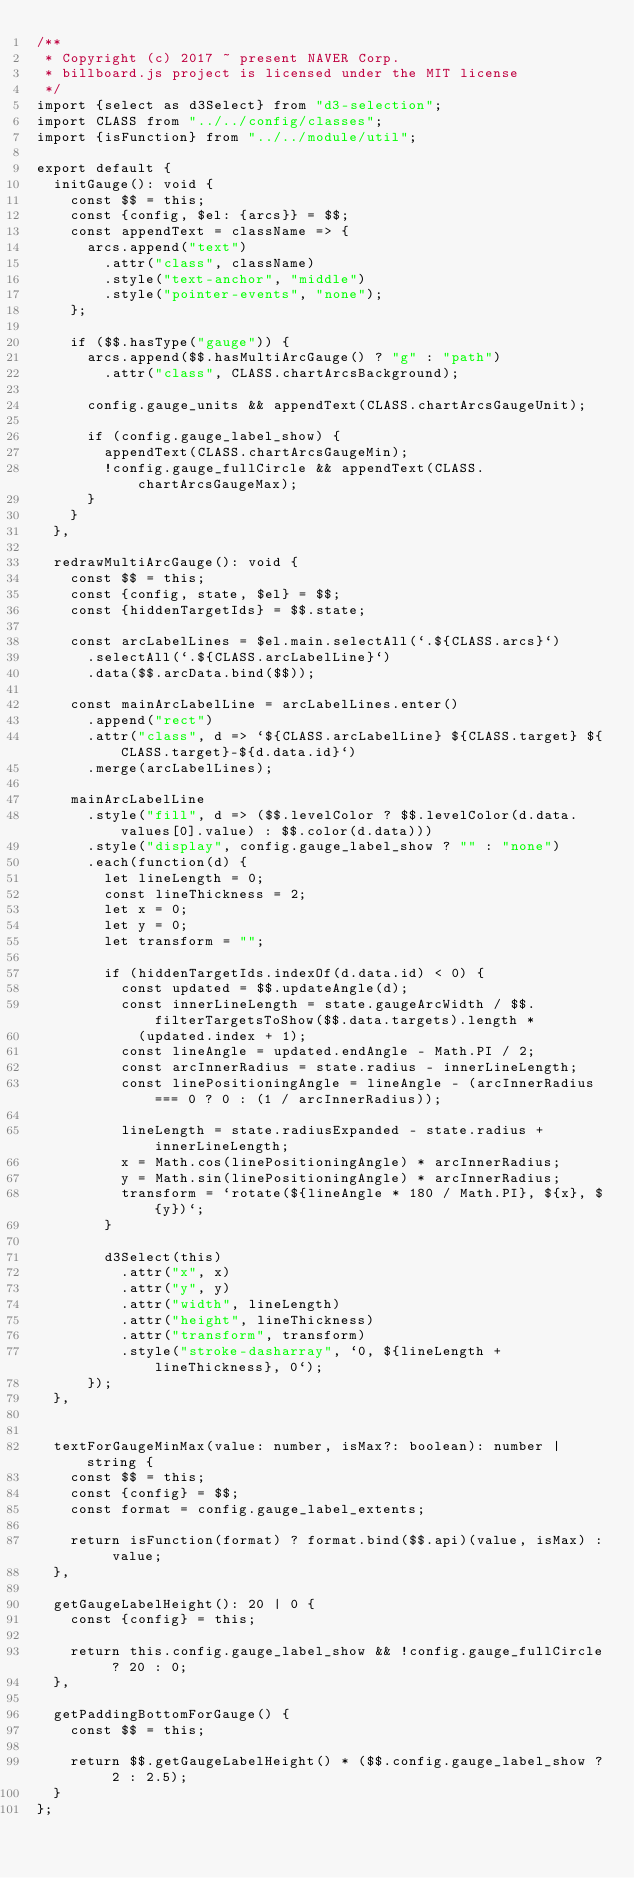<code> <loc_0><loc_0><loc_500><loc_500><_TypeScript_>/**
 * Copyright (c) 2017 ~ present NAVER Corp.
 * billboard.js project is licensed under the MIT license
 */
import {select as d3Select} from "d3-selection";
import CLASS from "../../config/classes";
import {isFunction} from "../../module/util";

export default {
	initGauge(): void {
		const $$ = this;
		const {config, $el: {arcs}} = $$;
		const appendText = className => {
			arcs.append("text")
				.attr("class", className)
				.style("text-anchor", "middle")
				.style("pointer-events", "none");
		};

		if ($$.hasType("gauge")) {
			arcs.append($$.hasMultiArcGauge() ? "g" : "path")
				.attr("class", CLASS.chartArcsBackground);

			config.gauge_units && appendText(CLASS.chartArcsGaugeUnit);

			if (config.gauge_label_show) {
				appendText(CLASS.chartArcsGaugeMin);
				!config.gauge_fullCircle && appendText(CLASS.chartArcsGaugeMax);
			}
		}
	},

	redrawMultiArcGauge(): void {
		const $$ = this;
		const {config, state, $el} = $$;
		const {hiddenTargetIds} = $$.state;

		const arcLabelLines = $el.main.selectAll(`.${CLASS.arcs}`)
			.selectAll(`.${CLASS.arcLabelLine}`)
			.data($$.arcData.bind($$));

		const mainArcLabelLine = arcLabelLines.enter()
			.append("rect")
			.attr("class", d => `${CLASS.arcLabelLine} ${CLASS.target} ${CLASS.target}-${d.data.id}`)
			.merge(arcLabelLines);

		mainArcLabelLine
			.style("fill", d => ($$.levelColor ? $$.levelColor(d.data.values[0].value) : $$.color(d.data)))
			.style("display", config.gauge_label_show ? "" : "none")
			.each(function(d) {
				let lineLength = 0;
				const lineThickness = 2;
				let x = 0;
				let y = 0;
				let transform = "";

				if (hiddenTargetIds.indexOf(d.data.id) < 0) {
					const updated = $$.updateAngle(d);
					const innerLineLength = state.gaugeArcWidth / $$.filterTargetsToShow($$.data.targets).length *
						(updated.index + 1);
					const lineAngle = updated.endAngle - Math.PI / 2;
					const arcInnerRadius = state.radius - innerLineLength;
					const linePositioningAngle = lineAngle - (arcInnerRadius === 0 ? 0 : (1 / arcInnerRadius));

					lineLength = state.radiusExpanded - state.radius + innerLineLength;
					x = Math.cos(linePositioningAngle) * arcInnerRadius;
					y = Math.sin(linePositioningAngle) * arcInnerRadius;
					transform = `rotate(${lineAngle * 180 / Math.PI}, ${x}, ${y})`;
				}

				d3Select(this)
					.attr("x", x)
					.attr("y", y)
					.attr("width", lineLength)
					.attr("height", lineThickness)
					.attr("transform", transform)
					.style("stroke-dasharray", `0, ${lineLength + lineThickness}, 0`);
			});
	},


	textForGaugeMinMax(value: number, isMax?: boolean): number | string {
		const $$ = this;
		const {config} = $$;
		const format = config.gauge_label_extents;

		return isFunction(format) ? format.bind($$.api)(value, isMax) : value;
	},

	getGaugeLabelHeight(): 20 | 0 {
		const {config} = this;

		return this.config.gauge_label_show && !config.gauge_fullCircle ? 20 : 0;
	},

	getPaddingBottomForGauge() {
		const $$ = this;

		return $$.getGaugeLabelHeight() * ($$.config.gauge_label_show ? 2 : 2.5);
	}
};
</code> 